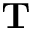Convert formula to latex. <formula><loc_0><loc_0><loc_500><loc_500>T</formula> 